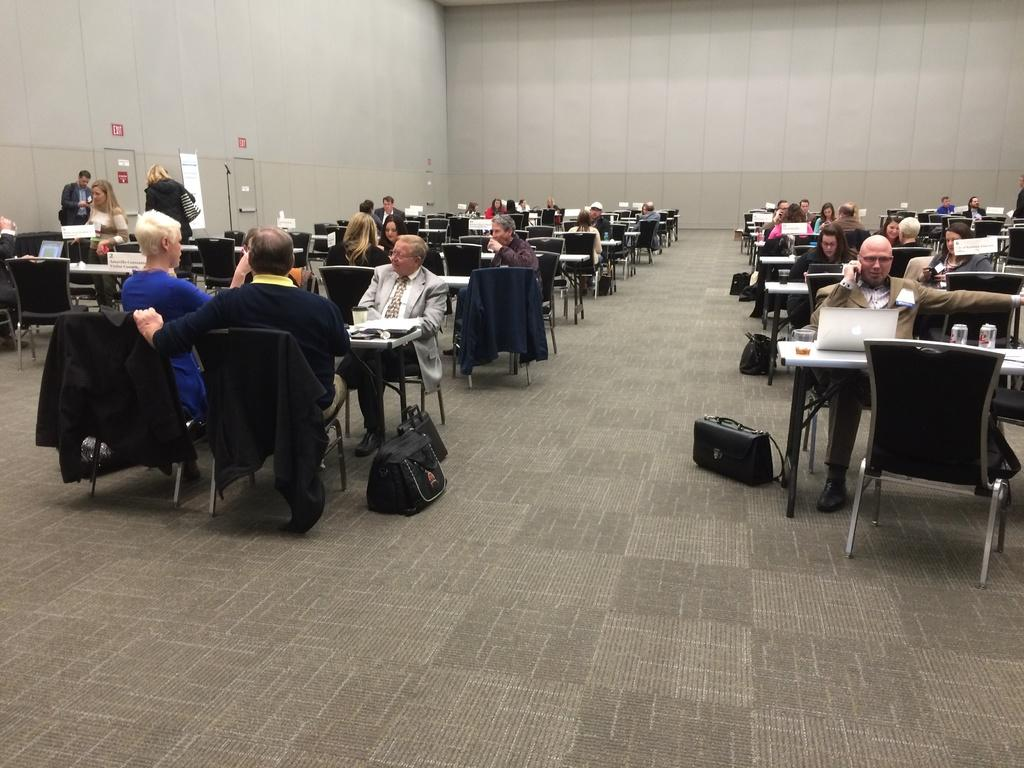What is happening on the left side of the image? There are people sitting on chairs on the left side of the image, and they are talking. How many people are on the left side of the image? There is no specific number mentioned, but there are people sitting on chairs and talking. What is the person on the right side of the image doing? The person on the right side of the image is using a laptop. Can you describe the activity of the person on the right side of the image? The person is using a laptop, which suggests they might be working or browsing the internet. Is the owner of the laptop sleeping in the image? There is no information about the owner of the laptop in the image, and no one is depicted as sleeping. Can you see a hook hanging from the ceiling in the image? There is no mention of a hook in the provided facts, and no hook is visible in the image. 